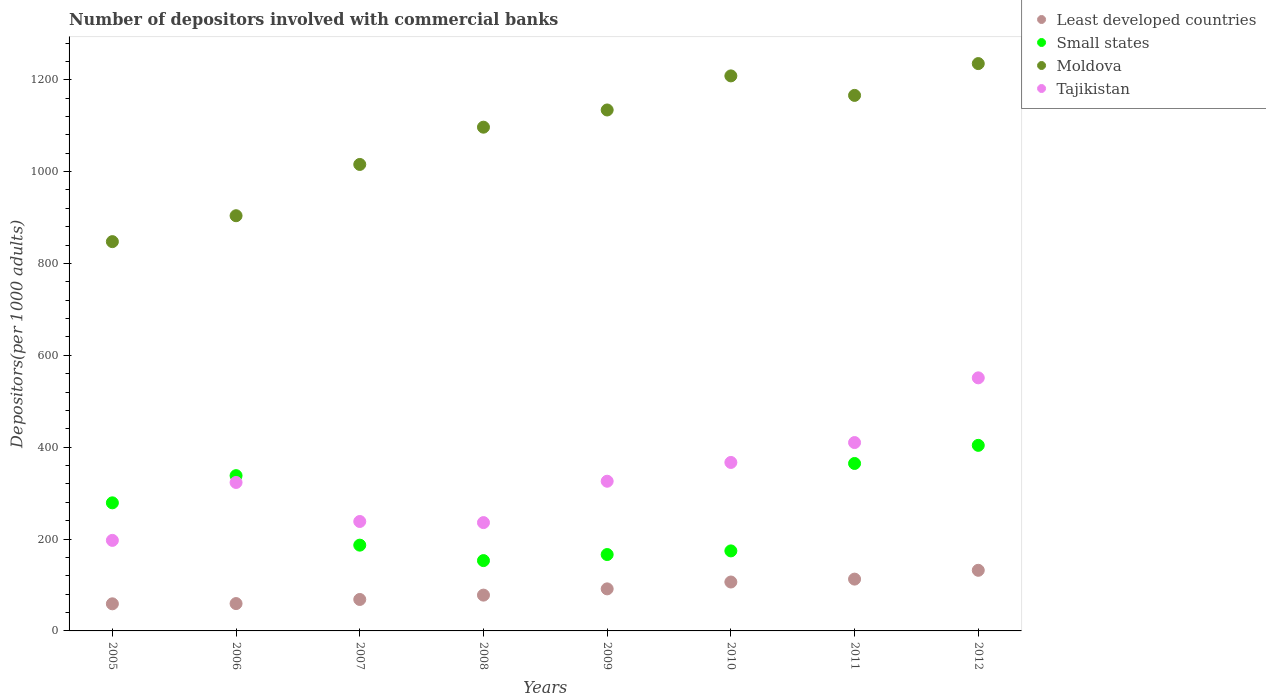How many different coloured dotlines are there?
Provide a short and direct response. 4. What is the number of depositors involved with commercial banks in Tajikistan in 2010?
Give a very brief answer. 366.8. Across all years, what is the maximum number of depositors involved with commercial banks in Tajikistan?
Provide a short and direct response. 550.99. Across all years, what is the minimum number of depositors involved with commercial banks in Moldova?
Your response must be concise. 847.53. What is the total number of depositors involved with commercial banks in Tajikistan in the graph?
Your response must be concise. 2648.21. What is the difference between the number of depositors involved with commercial banks in Least developed countries in 2005 and that in 2010?
Keep it short and to the point. -47.47. What is the difference between the number of depositors involved with commercial banks in Least developed countries in 2008 and the number of depositors involved with commercial banks in Moldova in 2012?
Your answer should be compact. -1157.23. What is the average number of depositors involved with commercial banks in Moldova per year?
Make the answer very short. 1075.94. In the year 2010, what is the difference between the number of depositors involved with commercial banks in Small states and number of depositors involved with commercial banks in Tajikistan?
Offer a terse response. -192.58. In how many years, is the number of depositors involved with commercial banks in Least developed countries greater than 640?
Your answer should be very brief. 0. What is the ratio of the number of depositors involved with commercial banks in Tajikistan in 2005 to that in 2007?
Keep it short and to the point. 0.83. Is the number of depositors involved with commercial banks in Moldova in 2006 less than that in 2012?
Your answer should be very brief. Yes. What is the difference between the highest and the second highest number of depositors involved with commercial banks in Tajikistan?
Offer a terse response. 140.89. What is the difference between the highest and the lowest number of depositors involved with commercial banks in Least developed countries?
Your response must be concise. 72.97. Is it the case that in every year, the sum of the number of depositors involved with commercial banks in Small states and number of depositors involved with commercial banks in Moldova  is greater than the number of depositors involved with commercial banks in Least developed countries?
Your answer should be compact. Yes. Does the number of depositors involved with commercial banks in Tajikistan monotonically increase over the years?
Offer a terse response. No. Is the number of depositors involved with commercial banks in Moldova strictly less than the number of depositors involved with commercial banks in Least developed countries over the years?
Keep it short and to the point. No. How many dotlines are there?
Your answer should be compact. 4. Are the values on the major ticks of Y-axis written in scientific E-notation?
Make the answer very short. No. Does the graph contain any zero values?
Make the answer very short. No. Does the graph contain grids?
Provide a succinct answer. No. Where does the legend appear in the graph?
Offer a terse response. Top right. What is the title of the graph?
Your answer should be compact. Number of depositors involved with commercial banks. Does "Nepal" appear as one of the legend labels in the graph?
Your response must be concise. No. What is the label or title of the X-axis?
Keep it short and to the point. Years. What is the label or title of the Y-axis?
Your answer should be compact. Depositors(per 1000 adults). What is the Depositors(per 1000 adults) of Least developed countries in 2005?
Keep it short and to the point. 59.02. What is the Depositors(per 1000 adults) of Small states in 2005?
Your answer should be very brief. 278.86. What is the Depositors(per 1000 adults) in Moldova in 2005?
Offer a very short reply. 847.53. What is the Depositors(per 1000 adults) in Tajikistan in 2005?
Offer a very short reply. 197.12. What is the Depositors(per 1000 adults) of Least developed countries in 2006?
Your answer should be compact. 59.54. What is the Depositors(per 1000 adults) in Small states in 2006?
Your response must be concise. 338.08. What is the Depositors(per 1000 adults) of Moldova in 2006?
Offer a terse response. 903.95. What is the Depositors(per 1000 adults) in Tajikistan in 2006?
Give a very brief answer. 323.23. What is the Depositors(per 1000 adults) in Least developed countries in 2007?
Offer a terse response. 68.48. What is the Depositors(per 1000 adults) of Small states in 2007?
Provide a short and direct response. 186.74. What is the Depositors(per 1000 adults) of Moldova in 2007?
Provide a succinct answer. 1015.6. What is the Depositors(per 1000 adults) in Tajikistan in 2007?
Give a very brief answer. 238.26. What is the Depositors(per 1000 adults) in Least developed countries in 2008?
Your answer should be compact. 77.95. What is the Depositors(per 1000 adults) of Small states in 2008?
Give a very brief answer. 153.11. What is the Depositors(per 1000 adults) in Moldova in 2008?
Keep it short and to the point. 1096.73. What is the Depositors(per 1000 adults) of Tajikistan in 2008?
Your answer should be very brief. 235.83. What is the Depositors(per 1000 adults) in Least developed countries in 2009?
Offer a very short reply. 91.54. What is the Depositors(per 1000 adults) of Small states in 2009?
Provide a succinct answer. 166.31. What is the Depositors(per 1000 adults) in Moldova in 2009?
Your answer should be compact. 1134.17. What is the Depositors(per 1000 adults) of Tajikistan in 2009?
Your answer should be very brief. 325.89. What is the Depositors(per 1000 adults) in Least developed countries in 2010?
Your answer should be very brief. 106.48. What is the Depositors(per 1000 adults) in Small states in 2010?
Give a very brief answer. 174.21. What is the Depositors(per 1000 adults) in Moldova in 2010?
Offer a terse response. 1208.39. What is the Depositors(per 1000 adults) of Tajikistan in 2010?
Your answer should be very brief. 366.8. What is the Depositors(per 1000 adults) of Least developed countries in 2011?
Offer a terse response. 112.8. What is the Depositors(per 1000 adults) of Small states in 2011?
Your response must be concise. 364.57. What is the Depositors(per 1000 adults) of Moldova in 2011?
Provide a succinct answer. 1165.93. What is the Depositors(per 1000 adults) in Tajikistan in 2011?
Give a very brief answer. 410.1. What is the Depositors(per 1000 adults) in Least developed countries in 2012?
Provide a succinct answer. 131.99. What is the Depositors(per 1000 adults) in Small states in 2012?
Ensure brevity in your answer.  404.02. What is the Depositors(per 1000 adults) in Moldova in 2012?
Make the answer very short. 1235.18. What is the Depositors(per 1000 adults) of Tajikistan in 2012?
Make the answer very short. 550.99. Across all years, what is the maximum Depositors(per 1000 adults) of Least developed countries?
Your response must be concise. 131.99. Across all years, what is the maximum Depositors(per 1000 adults) in Small states?
Give a very brief answer. 404.02. Across all years, what is the maximum Depositors(per 1000 adults) in Moldova?
Provide a short and direct response. 1235.18. Across all years, what is the maximum Depositors(per 1000 adults) of Tajikistan?
Provide a short and direct response. 550.99. Across all years, what is the minimum Depositors(per 1000 adults) in Least developed countries?
Provide a short and direct response. 59.02. Across all years, what is the minimum Depositors(per 1000 adults) in Small states?
Provide a short and direct response. 153.11. Across all years, what is the minimum Depositors(per 1000 adults) in Moldova?
Your response must be concise. 847.53. Across all years, what is the minimum Depositors(per 1000 adults) of Tajikistan?
Provide a short and direct response. 197.12. What is the total Depositors(per 1000 adults) in Least developed countries in the graph?
Give a very brief answer. 707.8. What is the total Depositors(per 1000 adults) in Small states in the graph?
Provide a short and direct response. 2065.89. What is the total Depositors(per 1000 adults) of Moldova in the graph?
Provide a succinct answer. 8607.5. What is the total Depositors(per 1000 adults) of Tajikistan in the graph?
Provide a succinct answer. 2648.21. What is the difference between the Depositors(per 1000 adults) in Least developed countries in 2005 and that in 2006?
Provide a succinct answer. -0.52. What is the difference between the Depositors(per 1000 adults) in Small states in 2005 and that in 2006?
Make the answer very short. -59.21. What is the difference between the Depositors(per 1000 adults) in Moldova in 2005 and that in 2006?
Your response must be concise. -56.41. What is the difference between the Depositors(per 1000 adults) in Tajikistan in 2005 and that in 2006?
Your response must be concise. -126.11. What is the difference between the Depositors(per 1000 adults) in Least developed countries in 2005 and that in 2007?
Your answer should be very brief. -9.47. What is the difference between the Depositors(per 1000 adults) of Small states in 2005 and that in 2007?
Offer a terse response. 92.12. What is the difference between the Depositors(per 1000 adults) of Moldova in 2005 and that in 2007?
Your answer should be compact. -168.07. What is the difference between the Depositors(per 1000 adults) in Tajikistan in 2005 and that in 2007?
Provide a succinct answer. -41.14. What is the difference between the Depositors(per 1000 adults) in Least developed countries in 2005 and that in 2008?
Your answer should be very brief. -18.94. What is the difference between the Depositors(per 1000 adults) of Small states in 2005 and that in 2008?
Provide a succinct answer. 125.76. What is the difference between the Depositors(per 1000 adults) of Moldova in 2005 and that in 2008?
Make the answer very short. -249.19. What is the difference between the Depositors(per 1000 adults) in Tajikistan in 2005 and that in 2008?
Your answer should be compact. -38.71. What is the difference between the Depositors(per 1000 adults) in Least developed countries in 2005 and that in 2009?
Keep it short and to the point. -32.53. What is the difference between the Depositors(per 1000 adults) of Small states in 2005 and that in 2009?
Your answer should be compact. 112.56. What is the difference between the Depositors(per 1000 adults) of Moldova in 2005 and that in 2009?
Give a very brief answer. -286.64. What is the difference between the Depositors(per 1000 adults) in Tajikistan in 2005 and that in 2009?
Ensure brevity in your answer.  -128.77. What is the difference between the Depositors(per 1000 adults) in Least developed countries in 2005 and that in 2010?
Offer a very short reply. -47.47. What is the difference between the Depositors(per 1000 adults) of Small states in 2005 and that in 2010?
Provide a succinct answer. 104.65. What is the difference between the Depositors(per 1000 adults) of Moldova in 2005 and that in 2010?
Your answer should be very brief. -360.86. What is the difference between the Depositors(per 1000 adults) of Tajikistan in 2005 and that in 2010?
Your answer should be compact. -169.68. What is the difference between the Depositors(per 1000 adults) of Least developed countries in 2005 and that in 2011?
Keep it short and to the point. -53.78. What is the difference between the Depositors(per 1000 adults) in Small states in 2005 and that in 2011?
Your response must be concise. -85.7. What is the difference between the Depositors(per 1000 adults) in Moldova in 2005 and that in 2011?
Give a very brief answer. -318.4. What is the difference between the Depositors(per 1000 adults) of Tajikistan in 2005 and that in 2011?
Give a very brief answer. -212.98. What is the difference between the Depositors(per 1000 adults) of Least developed countries in 2005 and that in 2012?
Offer a terse response. -72.97. What is the difference between the Depositors(per 1000 adults) of Small states in 2005 and that in 2012?
Offer a very short reply. -125.15. What is the difference between the Depositors(per 1000 adults) of Moldova in 2005 and that in 2012?
Ensure brevity in your answer.  -387.65. What is the difference between the Depositors(per 1000 adults) in Tajikistan in 2005 and that in 2012?
Ensure brevity in your answer.  -353.87. What is the difference between the Depositors(per 1000 adults) of Least developed countries in 2006 and that in 2007?
Give a very brief answer. -8.94. What is the difference between the Depositors(per 1000 adults) of Small states in 2006 and that in 2007?
Your answer should be compact. 151.33. What is the difference between the Depositors(per 1000 adults) in Moldova in 2006 and that in 2007?
Your response must be concise. -111.65. What is the difference between the Depositors(per 1000 adults) in Tajikistan in 2006 and that in 2007?
Provide a succinct answer. 84.98. What is the difference between the Depositors(per 1000 adults) of Least developed countries in 2006 and that in 2008?
Your response must be concise. -18.41. What is the difference between the Depositors(per 1000 adults) in Small states in 2006 and that in 2008?
Your answer should be compact. 184.97. What is the difference between the Depositors(per 1000 adults) in Moldova in 2006 and that in 2008?
Provide a short and direct response. -192.78. What is the difference between the Depositors(per 1000 adults) of Tajikistan in 2006 and that in 2008?
Your answer should be very brief. 87.4. What is the difference between the Depositors(per 1000 adults) in Least developed countries in 2006 and that in 2009?
Your answer should be very brief. -32. What is the difference between the Depositors(per 1000 adults) of Small states in 2006 and that in 2009?
Your answer should be compact. 171.77. What is the difference between the Depositors(per 1000 adults) in Moldova in 2006 and that in 2009?
Your answer should be compact. -230.23. What is the difference between the Depositors(per 1000 adults) in Tajikistan in 2006 and that in 2009?
Offer a very short reply. -2.66. What is the difference between the Depositors(per 1000 adults) of Least developed countries in 2006 and that in 2010?
Offer a very short reply. -46.94. What is the difference between the Depositors(per 1000 adults) in Small states in 2006 and that in 2010?
Keep it short and to the point. 163.86. What is the difference between the Depositors(per 1000 adults) of Moldova in 2006 and that in 2010?
Ensure brevity in your answer.  -304.44. What is the difference between the Depositors(per 1000 adults) of Tajikistan in 2006 and that in 2010?
Ensure brevity in your answer.  -43.56. What is the difference between the Depositors(per 1000 adults) in Least developed countries in 2006 and that in 2011?
Offer a terse response. -53.26. What is the difference between the Depositors(per 1000 adults) in Small states in 2006 and that in 2011?
Give a very brief answer. -26.49. What is the difference between the Depositors(per 1000 adults) of Moldova in 2006 and that in 2011?
Offer a very short reply. -261.98. What is the difference between the Depositors(per 1000 adults) in Tajikistan in 2006 and that in 2011?
Your answer should be very brief. -86.87. What is the difference between the Depositors(per 1000 adults) in Least developed countries in 2006 and that in 2012?
Provide a short and direct response. -72.45. What is the difference between the Depositors(per 1000 adults) in Small states in 2006 and that in 2012?
Offer a terse response. -65.94. What is the difference between the Depositors(per 1000 adults) in Moldova in 2006 and that in 2012?
Give a very brief answer. -331.24. What is the difference between the Depositors(per 1000 adults) in Tajikistan in 2006 and that in 2012?
Make the answer very short. -227.76. What is the difference between the Depositors(per 1000 adults) in Least developed countries in 2007 and that in 2008?
Give a very brief answer. -9.47. What is the difference between the Depositors(per 1000 adults) of Small states in 2007 and that in 2008?
Make the answer very short. 33.63. What is the difference between the Depositors(per 1000 adults) of Moldova in 2007 and that in 2008?
Give a very brief answer. -81.13. What is the difference between the Depositors(per 1000 adults) in Tajikistan in 2007 and that in 2008?
Offer a terse response. 2.43. What is the difference between the Depositors(per 1000 adults) in Least developed countries in 2007 and that in 2009?
Keep it short and to the point. -23.06. What is the difference between the Depositors(per 1000 adults) of Small states in 2007 and that in 2009?
Provide a short and direct response. 20.43. What is the difference between the Depositors(per 1000 adults) of Moldova in 2007 and that in 2009?
Provide a short and direct response. -118.57. What is the difference between the Depositors(per 1000 adults) in Tajikistan in 2007 and that in 2009?
Your answer should be very brief. -87.64. What is the difference between the Depositors(per 1000 adults) of Least developed countries in 2007 and that in 2010?
Make the answer very short. -38. What is the difference between the Depositors(per 1000 adults) of Small states in 2007 and that in 2010?
Provide a succinct answer. 12.53. What is the difference between the Depositors(per 1000 adults) in Moldova in 2007 and that in 2010?
Your answer should be compact. -192.79. What is the difference between the Depositors(per 1000 adults) of Tajikistan in 2007 and that in 2010?
Your answer should be very brief. -128.54. What is the difference between the Depositors(per 1000 adults) in Least developed countries in 2007 and that in 2011?
Offer a terse response. -44.32. What is the difference between the Depositors(per 1000 adults) in Small states in 2007 and that in 2011?
Offer a terse response. -177.83. What is the difference between the Depositors(per 1000 adults) in Moldova in 2007 and that in 2011?
Your answer should be very brief. -150.33. What is the difference between the Depositors(per 1000 adults) in Tajikistan in 2007 and that in 2011?
Keep it short and to the point. -171.84. What is the difference between the Depositors(per 1000 adults) in Least developed countries in 2007 and that in 2012?
Your answer should be very brief. -63.51. What is the difference between the Depositors(per 1000 adults) of Small states in 2007 and that in 2012?
Offer a very short reply. -217.28. What is the difference between the Depositors(per 1000 adults) of Moldova in 2007 and that in 2012?
Provide a succinct answer. -219.58. What is the difference between the Depositors(per 1000 adults) in Tajikistan in 2007 and that in 2012?
Provide a succinct answer. -312.74. What is the difference between the Depositors(per 1000 adults) of Least developed countries in 2008 and that in 2009?
Your response must be concise. -13.59. What is the difference between the Depositors(per 1000 adults) of Small states in 2008 and that in 2009?
Your answer should be very brief. -13.2. What is the difference between the Depositors(per 1000 adults) of Moldova in 2008 and that in 2009?
Provide a succinct answer. -37.44. What is the difference between the Depositors(per 1000 adults) in Tajikistan in 2008 and that in 2009?
Provide a succinct answer. -90.06. What is the difference between the Depositors(per 1000 adults) in Least developed countries in 2008 and that in 2010?
Your response must be concise. -28.53. What is the difference between the Depositors(per 1000 adults) in Small states in 2008 and that in 2010?
Your answer should be very brief. -21.11. What is the difference between the Depositors(per 1000 adults) of Moldova in 2008 and that in 2010?
Your answer should be compact. -111.66. What is the difference between the Depositors(per 1000 adults) of Tajikistan in 2008 and that in 2010?
Give a very brief answer. -130.97. What is the difference between the Depositors(per 1000 adults) in Least developed countries in 2008 and that in 2011?
Make the answer very short. -34.85. What is the difference between the Depositors(per 1000 adults) of Small states in 2008 and that in 2011?
Your response must be concise. -211.46. What is the difference between the Depositors(per 1000 adults) of Moldova in 2008 and that in 2011?
Offer a terse response. -69.2. What is the difference between the Depositors(per 1000 adults) of Tajikistan in 2008 and that in 2011?
Ensure brevity in your answer.  -174.27. What is the difference between the Depositors(per 1000 adults) in Least developed countries in 2008 and that in 2012?
Provide a short and direct response. -54.04. What is the difference between the Depositors(per 1000 adults) in Small states in 2008 and that in 2012?
Make the answer very short. -250.91. What is the difference between the Depositors(per 1000 adults) of Moldova in 2008 and that in 2012?
Your answer should be compact. -138.45. What is the difference between the Depositors(per 1000 adults) in Tajikistan in 2008 and that in 2012?
Provide a succinct answer. -315.16. What is the difference between the Depositors(per 1000 adults) of Least developed countries in 2009 and that in 2010?
Offer a terse response. -14.94. What is the difference between the Depositors(per 1000 adults) in Small states in 2009 and that in 2010?
Provide a succinct answer. -7.91. What is the difference between the Depositors(per 1000 adults) in Moldova in 2009 and that in 2010?
Provide a succinct answer. -74.22. What is the difference between the Depositors(per 1000 adults) in Tajikistan in 2009 and that in 2010?
Offer a terse response. -40.9. What is the difference between the Depositors(per 1000 adults) in Least developed countries in 2009 and that in 2011?
Keep it short and to the point. -21.26. What is the difference between the Depositors(per 1000 adults) of Small states in 2009 and that in 2011?
Your answer should be very brief. -198.26. What is the difference between the Depositors(per 1000 adults) in Moldova in 2009 and that in 2011?
Offer a very short reply. -31.76. What is the difference between the Depositors(per 1000 adults) of Tajikistan in 2009 and that in 2011?
Your response must be concise. -84.21. What is the difference between the Depositors(per 1000 adults) of Least developed countries in 2009 and that in 2012?
Make the answer very short. -40.44. What is the difference between the Depositors(per 1000 adults) of Small states in 2009 and that in 2012?
Provide a succinct answer. -237.71. What is the difference between the Depositors(per 1000 adults) of Moldova in 2009 and that in 2012?
Provide a succinct answer. -101.01. What is the difference between the Depositors(per 1000 adults) in Tajikistan in 2009 and that in 2012?
Provide a short and direct response. -225.1. What is the difference between the Depositors(per 1000 adults) in Least developed countries in 2010 and that in 2011?
Your answer should be compact. -6.32. What is the difference between the Depositors(per 1000 adults) of Small states in 2010 and that in 2011?
Give a very brief answer. -190.35. What is the difference between the Depositors(per 1000 adults) of Moldova in 2010 and that in 2011?
Your response must be concise. 42.46. What is the difference between the Depositors(per 1000 adults) of Tajikistan in 2010 and that in 2011?
Your answer should be compact. -43.3. What is the difference between the Depositors(per 1000 adults) in Least developed countries in 2010 and that in 2012?
Your response must be concise. -25.51. What is the difference between the Depositors(per 1000 adults) of Small states in 2010 and that in 2012?
Make the answer very short. -229.8. What is the difference between the Depositors(per 1000 adults) in Moldova in 2010 and that in 2012?
Offer a terse response. -26.79. What is the difference between the Depositors(per 1000 adults) of Tajikistan in 2010 and that in 2012?
Your answer should be compact. -184.2. What is the difference between the Depositors(per 1000 adults) in Least developed countries in 2011 and that in 2012?
Your response must be concise. -19.19. What is the difference between the Depositors(per 1000 adults) in Small states in 2011 and that in 2012?
Your answer should be compact. -39.45. What is the difference between the Depositors(per 1000 adults) of Moldova in 2011 and that in 2012?
Ensure brevity in your answer.  -69.25. What is the difference between the Depositors(per 1000 adults) in Tajikistan in 2011 and that in 2012?
Offer a very short reply. -140.89. What is the difference between the Depositors(per 1000 adults) of Least developed countries in 2005 and the Depositors(per 1000 adults) of Small states in 2006?
Your answer should be compact. -279.06. What is the difference between the Depositors(per 1000 adults) in Least developed countries in 2005 and the Depositors(per 1000 adults) in Moldova in 2006?
Your response must be concise. -844.93. What is the difference between the Depositors(per 1000 adults) in Least developed countries in 2005 and the Depositors(per 1000 adults) in Tajikistan in 2006?
Your answer should be very brief. -264.22. What is the difference between the Depositors(per 1000 adults) of Small states in 2005 and the Depositors(per 1000 adults) of Moldova in 2006?
Provide a short and direct response. -625.09. What is the difference between the Depositors(per 1000 adults) in Small states in 2005 and the Depositors(per 1000 adults) in Tajikistan in 2006?
Your answer should be very brief. -44.37. What is the difference between the Depositors(per 1000 adults) in Moldova in 2005 and the Depositors(per 1000 adults) in Tajikistan in 2006?
Offer a very short reply. 524.3. What is the difference between the Depositors(per 1000 adults) in Least developed countries in 2005 and the Depositors(per 1000 adults) in Small states in 2007?
Provide a succinct answer. -127.73. What is the difference between the Depositors(per 1000 adults) of Least developed countries in 2005 and the Depositors(per 1000 adults) of Moldova in 2007?
Your answer should be compact. -956.59. What is the difference between the Depositors(per 1000 adults) of Least developed countries in 2005 and the Depositors(per 1000 adults) of Tajikistan in 2007?
Ensure brevity in your answer.  -179.24. What is the difference between the Depositors(per 1000 adults) of Small states in 2005 and the Depositors(per 1000 adults) of Moldova in 2007?
Provide a short and direct response. -736.74. What is the difference between the Depositors(per 1000 adults) in Small states in 2005 and the Depositors(per 1000 adults) in Tajikistan in 2007?
Your answer should be compact. 40.61. What is the difference between the Depositors(per 1000 adults) of Moldova in 2005 and the Depositors(per 1000 adults) of Tajikistan in 2007?
Keep it short and to the point. 609.28. What is the difference between the Depositors(per 1000 adults) in Least developed countries in 2005 and the Depositors(per 1000 adults) in Small states in 2008?
Keep it short and to the point. -94.09. What is the difference between the Depositors(per 1000 adults) in Least developed countries in 2005 and the Depositors(per 1000 adults) in Moldova in 2008?
Provide a succinct answer. -1037.71. What is the difference between the Depositors(per 1000 adults) in Least developed countries in 2005 and the Depositors(per 1000 adults) in Tajikistan in 2008?
Keep it short and to the point. -176.81. What is the difference between the Depositors(per 1000 adults) in Small states in 2005 and the Depositors(per 1000 adults) in Moldova in 2008?
Your response must be concise. -817.87. What is the difference between the Depositors(per 1000 adults) of Small states in 2005 and the Depositors(per 1000 adults) of Tajikistan in 2008?
Your response must be concise. 43.04. What is the difference between the Depositors(per 1000 adults) of Moldova in 2005 and the Depositors(per 1000 adults) of Tajikistan in 2008?
Your answer should be compact. 611.71. What is the difference between the Depositors(per 1000 adults) of Least developed countries in 2005 and the Depositors(per 1000 adults) of Small states in 2009?
Your answer should be very brief. -107.29. What is the difference between the Depositors(per 1000 adults) of Least developed countries in 2005 and the Depositors(per 1000 adults) of Moldova in 2009?
Offer a terse response. -1075.16. What is the difference between the Depositors(per 1000 adults) of Least developed countries in 2005 and the Depositors(per 1000 adults) of Tajikistan in 2009?
Ensure brevity in your answer.  -266.88. What is the difference between the Depositors(per 1000 adults) in Small states in 2005 and the Depositors(per 1000 adults) in Moldova in 2009?
Keep it short and to the point. -855.31. What is the difference between the Depositors(per 1000 adults) of Small states in 2005 and the Depositors(per 1000 adults) of Tajikistan in 2009?
Offer a very short reply. -47.03. What is the difference between the Depositors(per 1000 adults) of Moldova in 2005 and the Depositors(per 1000 adults) of Tajikistan in 2009?
Provide a succinct answer. 521.64. What is the difference between the Depositors(per 1000 adults) of Least developed countries in 2005 and the Depositors(per 1000 adults) of Small states in 2010?
Offer a very short reply. -115.2. What is the difference between the Depositors(per 1000 adults) in Least developed countries in 2005 and the Depositors(per 1000 adults) in Moldova in 2010?
Your answer should be compact. -1149.38. What is the difference between the Depositors(per 1000 adults) of Least developed countries in 2005 and the Depositors(per 1000 adults) of Tajikistan in 2010?
Keep it short and to the point. -307.78. What is the difference between the Depositors(per 1000 adults) of Small states in 2005 and the Depositors(per 1000 adults) of Moldova in 2010?
Provide a succinct answer. -929.53. What is the difference between the Depositors(per 1000 adults) of Small states in 2005 and the Depositors(per 1000 adults) of Tajikistan in 2010?
Your answer should be compact. -87.93. What is the difference between the Depositors(per 1000 adults) in Moldova in 2005 and the Depositors(per 1000 adults) in Tajikistan in 2010?
Keep it short and to the point. 480.74. What is the difference between the Depositors(per 1000 adults) in Least developed countries in 2005 and the Depositors(per 1000 adults) in Small states in 2011?
Your answer should be compact. -305.55. What is the difference between the Depositors(per 1000 adults) in Least developed countries in 2005 and the Depositors(per 1000 adults) in Moldova in 2011?
Provide a succinct answer. -1106.92. What is the difference between the Depositors(per 1000 adults) in Least developed countries in 2005 and the Depositors(per 1000 adults) in Tajikistan in 2011?
Provide a short and direct response. -351.08. What is the difference between the Depositors(per 1000 adults) of Small states in 2005 and the Depositors(per 1000 adults) of Moldova in 2011?
Provide a short and direct response. -887.07. What is the difference between the Depositors(per 1000 adults) of Small states in 2005 and the Depositors(per 1000 adults) of Tajikistan in 2011?
Your answer should be compact. -131.24. What is the difference between the Depositors(per 1000 adults) of Moldova in 2005 and the Depositors(per 1000 adults) of Tajikistan in 2011?
Offer a terse response. 437.44. What is the difference between the Depositors(per 1000 adults) of Least developed countries in 2005 and the Depositors(per 1000 adults) of Small states in 2012?
Keep it short and to the point. -345. What is the difference between the Depositors(per 1000 adults) of Least developed countries in 2005 and the Depositors(per 1000 adults) of Moldova in 2012?
Keep it short and to the point. -1176.17. What is the difference between the Depositors(per 1000 adults) in Least developed countries in 2005 and the Depositors(per 1000 adults) in Tajikistan in 2012?
Provide a succinct answer. -491.98. What is the difference between the Depositors(per 1000 adults) in Small states in 2005 and the Depositors(per 1000 adults) in Moldova in 2012?
Offer a very short reply. -956.32. What is the difference between the Depositors(per 1000 adults) of Small states in 2005 and the Depositors(per 1000 adults) of Tajikistan in 2012?
Your response must be concise. -272.13. What is the difference between the Depositors(per 1000 adults) in Moldova in 2005 and the Depositors(per 1000 adults) in Tajikistan in 2012?
Give a very brief answer. 296.54. What is the difference between the Depositors(per 1000 adults) of Least developed countries in 2006 and the Depositors(per 1000 adults) of Small states in 2007?
Make the answer very short. -127.2. What is the difference between the Depositors(per 1000 adults) in Least developed countries in 2006 and the Depositors(per 1000 adults) in Moldova in 2007?
Ensure brevity in your answer.  -956.06. What is the difference between the Depositors(per 1000 adults) of Least developed countries in 2006 and the Depositors(per 1000 adults) of Tajikistan in 2007?
Ensure brevity in your answer.  -178.72. What is the difference between the Depositors(per 1000 adults) in Small states in 2006 and the Depositors(per 1000 adults) in Moldova in 2007?
Provide a succinct answer. -677.53. What is the difference between the Depositors(per 1000 adults) in Small states in 2006 and the Depositors(per 1000 adults) in Tajikistan in 2007?
Keep it short and to the point. 99.82. What is the difference between the Depositors(per 1000 adults) in Moldova in 2006 and the Depositors(per 1000 adults) in Tajikistan in 2007?
Offer a terse response. 665.69. What is the difference between the Depositors(per 1000 adults) of Least developed countries in 2006 and the Depositors(per 1000 adults) of Small states in 2008?
Ensure brevity in your answer.  -93.57. What is the difference between the Depositors(per 1000 adults) of Least developed countries in 2006 and the Depositors(per 1000 adults) of Moldova in 2008?
Keep it short and to the point. -1037.19. What is the difference between the Depositors(per 1000 adults) of Least developed countries in 2006 and the Depositors(per 1000 adults) of Tajikistan in 2008?
Provide a short and direct response. -176.29. What is the difference between the Depositors(per 1000 adults) of Small states in 2006 and the Depositors(per 1000 adults) of Moldova in 2008?
Give a very brief answer. -758.65. What is the difference between the Depositors(per 1000 adults) of Small states in 2006 and the Depositors(per 1000 adults) of Tajikistan in 2008?
Make the answer very short. 102.25. What is the difference between the Depositors(per 1000 adults) in Moldova in 2006 and the Depositors(per 1000 adults) in Tajikistan in 2008?
Ensure brevity in your answer.  668.12. What is the difference between the Depositors(per 1000 adults) in Least developed countries in 2006 and the Depositors(per 1000 adults) in Small states in 2009?
Your answer should be very brief. -106.77. What is the difference between the Depositors(per 1000 adults) of Least developed countries in 2006 and the Depositors(per 1000 adults) of Moldova in 2009?
Make the answer very short. -1074.64. What is the difference between the Depositors(per 1000 adults) in Least developed countries in 2006 and the Depositors(per 1000 adults) in Tajikistan in 2009?
Make the answer very short. -266.35. What is the difference between the Depositors(per 1000 adults) of Small states in 2006 and the Depositors(per 1000 adults) of Moldova in 2009?
Provide a succinct answer. -796.1. What is the difference between the Depositors(per 1000 adults) of Small states in 2006 and the Depositors(per 1000 adults) of Tajikistan in 2009?
Ensure brevity in your answer.  12.18. What is the difference between the Depositors(per 1000 adults) of Moldova in 2006 and the Depositors(per 1000 adults) of Tajikistan in 2009?
Your answer should be compact. 578.06. What is the difference between the Depositors(per 1000 adults) in Least developed countries in 2006 and the Depositors(per 1000 adults) in Small states in 2010?
Provide a short and direct response. -114.68. What is the difference between the Depositors(per 1000 adults) of Least developed countries in 2006 and the Depositors(per 1000 adults) of Moldova in 2010?
Ensure brevity in your answer.  -1148.85. What is the difference between the Depositors(per 1000 adults) in Least developed countries in 2006 and the Depositors(per 1000 adults) in Tajikistan in 2010?
Keep it short and to the point. -307.26. What is the difference between the Depositors(per 1000 adults) of Small states in 2006 and the Depositors(per 1000 adults) of Moldova in 2010?
Provide a succinct answer. -870.32. What is the difference between the Depositors(per 1000 adults) of Small states in 2006 and the Depositors(per 1000 adults) of Tajikistan in 2010?
Your answer should be compact. -28.72. What is the difference between the Depositors(per 1000 adults) of Moldova in 2006 and the Depositors(per 1000 adults) of Tajikistan in 2010?
Make the answer very short. 537.15. What is the difference between the Depositors(per 1000 adults) in Least developed countries in 2006 and the Depositors(per 1000 adults) in Small states in 2011?
Provide a succinct answer. -305.03. What is the difference between the Depositors(per 1000 adults) of Least developed countries in 2006 and the Depositors(per 1000 adults) of Moldova in 2011?
Make the answer very short. -1106.39. What is the difference between the Depositors(per 1000 adults) in Least developed countries in 2006 and the Depositors(per 1000 adults) in Tajikistan in 2011?
Give a very brief answer. -350.56. What is the difference between the Depositors(per 1000 adults) in Small states in 2006 and the Depositors(per 1000 adults) in Moldova in 2011?
Your response must be concise. -827.86. What is the difference between the Depositors(per 1000 adults) in Small states in 2006 and the Depositors(per 1000 adults) in Tajikistan in 2011?
Provide a short and direct response. -72.02. What is the difference between the Depositors(per 1000 adults) in Moldova in 2006 and the Depositors(per 1000 adults) in Tajikistan in 2011?
Provide a succinct answer. 493.85. What is the difference between the Depositors(per 1000 adults) of Least developed countries in 2006 and the Depositors(per 1000 adults) of Small states in 2012?
Provide a short and direct response. -344.48. What is the difference between the Depositors(per 1000 adults) in Least developed countries in 2006 and the Depositors(per 1000 adults) in Moldova in 2012?
Your response must be concise. -1175.65. What is the difference between the Depositors(per 1000 adults) in Least developed countries in 2006 and the Depositors(per 1000 adults) in Tajikistan in 2012?
Your answer should be compact. -491.45. What is the difference between the Depositors(per 1000 adults) of Small states in 2006 and the Depositors(per 1000 adults) of Moldova in 2012?
Make the answer very short. -897.11. What is the difference between the Depositors(per 1000 adults) of Small states in 2006 and the Depositors(per 1000 adults) of Tajikistan in 2012?
Keep it short and to the point. -212.92. What is the difference between the Depositors(per 1000 adults) of Moldova in 2006 and the Depositors(per 1000 adults) of Tajikistan in 2012?
Your response must be concise. 352.96. What is the difference between the Depositors(per 1000 adults) in Least developed countries in 2007 and the Depositors(per 1000 adults) in Small states in 2008?
Keep it short and to the point. -84.63. What is the difference between the Depositors(per 1000 adults) of Least developed countries in 2007 and the Depositors(per 1000 adults) of Moldova in 2008?
Offer a terse response. -1028.25. What is the difference between the Depositors(per 1000 adults) of Least developed countries in 2007 and the Depositors(per 1000 adults) of Tajikistan in 2008?
Give a very brief answer. -167.35. What is the difference between the Depositors(per 1000 adults) of Small states in 2007 and the Depositors(per 1000 adults) of Moldova in 2008?
Provide a short and direct response. -909.99. What is the difference between the Depositors(per 1000 adults) of Small states in 2007 and the Depositors(per 1000 adults) of Tajikistan in 2008?
Your answer should be very brief. -49.09. What is the difference between the Depositors(per 1000 adults) of Moldova in 2007 and the Depositors(per 1000 adults) of Tajikistan in 2008?
Provide a short and direct response. 779.77. What is the difference between the Depositors(per 1000 adults) of Least developed countries in 2007 and the Depositors(per 1000 adults) of Small states in 2009?
Ensure brevity in your answer.  -97.83. What is the difference between the Depositors(per 1000 adults) of Least developed countries in 2007 and the Depositors(per 1000 adults) of Moldova in 2009?
Your response must be concise. -1065.69. What is the difference between the Depositors(per 1000 adults) of Least developed countries in 2007 and the Depositors(per 1000 adults) of Tajikistan in 2009?
Give a very brief answer. -257.41. What is the difference between the Depositors(per 1000 adults) of Small states in 2007 and the Depositors(per 1000 adults) of Moldova in 2009?
Your answer should be compact. -947.43. What is the difference between the Depositors(per 1000 adults) of Small states in 2007 and the Depositors(per 1000 adults) of Tajikistan in 2009?
Offer a very short reply. -139.15. What is the difference between the Depositors(per 1000 adults) in Moldova in 2007 and the Depositors(per 1000 adults) in Tajikistan in 2009?
Ensure brevity in your answer.  689.71. What is the difference between the Depositors(per 1000 adults) of Least developed countries in 2007 and the Depositors(per 1000 adults) of Small states in 2010?
Ensure brevity in your answer.  -105.73. What is the difference between the Depositors(per 1000 adults) in Least developed countries in 2007 and the Depositors(per 1000 adults) in Moldova in 2010?
Offer a terse response. -1139.91. What is the difference between the Depositors(per 1000 adults) in Least developed countries in 2007 and the Depositors(per 1000 adults) in Tajikistan in 2010?
Give a very brief answer. -298.32. What is the difference between the Depositors(per 1000 adults) of Small states in 2007 and the Depositors(per 1000 adults) of Moldova in 2010?
Make the answer very short. -1021.65. What is the difference between the Depositors(per 1000 adults) in Small states in 2007 and the Depositors(per 1000 adults) in Tajikistan in 2010?
Provide a succinct answer. -180.06. What is the difference between the Depositors(per 1000 adults) of Moldova in 2007 and the Depositors(per 1000 adults) of Tajikistan in 2010?
Your answer should be compact. 648.81. What is the difference between the Depositors(per 1000 adults) in Least developed countries in 2007 and the Depositors(per 1000 adults) in Small states in 2011?
Offer a very short reply. -296.09. What is the difference between the Depositors(per 1000 adults) of Least developed countries in 2007 and the Depositors(per 1000 adults) of Moldova in 2011?
Your response must be concise. -1097.45. What is the difference between the Depositors(per 1000 adults) in Least developed countries in 2007 and the Depositors(per 1000 adults) in Tajikistan in 2011?
Your answer should be compact. -341.62. What is the difference between the Depositors(per 1000 adults) in Small states in 2007 and the Depositors(per 1000 adults) in Moldova in 2011?
Offer a very short reply. -979.19. What is the difference between the Depositors(per 1000 adults) in Small states in 2007 and the Depositors(per 1000 adults) in Tajikistan in 2011?
Your answer should be compact. -223.36. What is the difference between the Depositors(per 1000 adults) in Moldova in 2007 and the Depositors(per 1000 adults) in Tajikistan in 2011?
Ensure brevity in your answer.  605.5. What is the difference between the Depositors(per 1000 adults) in Least developed countries in 2007 and the Depositors(per 1000 adults) in Small states in 2012?
Your response must be concise. -335.54. What is the difference between the Depositors(per 1000 adults) in Least developed countries in 2007 and the Depositors(per 1000 adults) in Moldova in 2012?
Offer a very short reply. -1166.7. What is the difference between the Depositors(per 1000 adults) of Least developed countries in 2007 and the Depositors(per 1000 adults) of Tajikistan in 2012?
Your answer should be compact. -482.51. What is the difference between the Depositors(per 1000 adults) of Small states in 2007 and the Depositors(per 1000 adults) of Moldova in 2012?
Offer a terse response. -1048.44. What is the difference between the Depositors(per 1000 adults) in Small states in 2007 and the Depositors(per 1000 adults) in Tajikistan in 2012?
Offer a very short reply. -364.25. What is the difference between the Depositors(per 1000 adults) in Moldova in 2007 and the Depositors(per 1000 adults) in Tajikistan in 2012?
Give a very brief answer. 464.61. What is the difference between the Depositors(per 1000 adults) of Least developed countries in 2008 and the Depositors(per 1000 adults) of Small states in 2009?
Give a very brief answer. -88.36. What is the difference between the Depositors(per 1000 adults) of Least developed countries in 2008 and the Depositors(per 1000 adults) of Moldova in 2009?
Your answer should be very brief. -1056.22. What is the difference between the Depositors(per 1000 adults) of Least developed countries in 2008 and the Depositors(per 1000 adults) of Tajikistan in 2009?
Ensure brevity in your answer.  -247.94. What is the difference between the Depositors(per 1000 adults) in Small states in 2008 and the Depositors(per 1000 adults) in Moldova in 2009?
Your answer should be compact. -981.07. What is the difference between the Depositors(per 1000 adults) in Small states in 2008 and the Depositors(per 1000 adults) in Tajikistan in 2009?
Keep it short and to the point. -172.79. What is the difference between the Depositors(per 1000 adults) of Moldova in 2008 and the Depositors(per 1000 adults) of Tajikistan in 2009?
Make the answer very short. 770.84. What is the difference between the Depositors(per 1000 adults) in Least developed countries in 2008 and the Depositors(per 1000 adults) in Small states in 2010?
Offer a terse response. -96.26. What is the difference between the Depositors(per 1000 adults) in Least developed countries in 2008 and the Depositors(per 1000 adults) in Moldova in 2010?
Provide a short and direct response. -1130.44. What is the difference between the Depositors(per 1000 adults) in Least developed countries in 2008 and the Depositors(per 1000 adults) in Tajikistan in 2010?
Your answer should be very brief. -288.85. What is the difference between the Depositors(per 1000 adults) in Small states in 2008 and the Depositors(per 1000 adults) in Moldova in 2010?
Keep it short and to the point. -1055.28. What is the difference between the Depositors(per 1000 adults) in Small states in 2008 and the Depositors(per 1000 adults) in Tajikistan in 2010?
Provide a succinct answer. -213.69. What is the difference between the Depositors(per 1000 adults) in Moldova in 2008 and the Depositors(per 1000 adults) in Tajikistan in 2010?
Provide a succinct answer. 729.93. What is the difference between the Depositors(per 1000 adults) of Least developed countries in 2008 and the Depositors(per 1000 adults) of Small states in 2011?
Make the answer very short. -286.62. What is the difference between the Depositors(per 1000 adults) of Least developed countries in 2008 and the Depositors(per 1000 adults) of Moldova in 2011?
Your answer should be compact. -1087.98. What is the difference between the Depositors(per 1000 adults) of Least developed countries in 2008 and the Depositors(per 1000 adults) of Tajikistan in 2011?
Give a very brief answer. -332.15. What is the difference between the Depositors(per 1000 adults) in Small states in 2008 and the Depositors(per 1000 adults) in Moldova in 2011?
Your answer should be compact. -1012.82. What is the difference between the Depositors(per 1000 adults) of Small states in 2008 and the Depositors(per 1000 adults) of Tajikistan in 2011?
Make the answer very short. -256.99. What is the difference between the Depositors(per 1000 adults) of Moldova in 2008 and the Depositors(per 1000 adults) of Tajikistan in 2011?
Your response must be concise. 686.63. What is the difference between the Depositors(per 1000 adults) of Least developed countries in 2008 and the Depositors(per 1000 adults) of Small states in 2012?
Your response must be concise. -326.07. What is the difference between the Depositors(per 1000 adults) of Least developed countries in 2008 and the Depositors(per 1000 adults) of Moldova in 2012?
Offer a very short reply. -1157.23. What is the difference between the Depositors(per 1000 adults) of Least developed countries in 2008 and the Depositors(per 1000 adults) of Tajikistan in 2012?
Your answer should be very brief. -473.04. What is the difference between the Depositors(per 1000 adults) of Small states in 2008 and the Depositors(per 1000 adults) of Moldova in 2012?
Your answer should be compact. -1082.08. What is the difference between the Depositors(per 1000 adults) in Small states in 2008 and the Depositors(per 1000 adults) in Tajikistan in 2012?
Provide a short and direct response. -397.89. What is the difference between the Depositors(per 1000 adults) of Moldova in 2008 and the Depositors(per 1000 adults) of Tajikistan in 2012?
Make the answer very short. 545.74. What is the difference between the Depositors(per 1000 adults) in Least developed countries in 2009 and the Depositors(per 1000 adults) in Small states in 2010?
Offer a terse response. -82.67. What is the difference between the Depositors(per 1000 adults) in Least developed countries in 2009 and the Depositors(per 1000 adults) in Moldova in 2010?
Make the answer very short. -1116.85. What is the difference between the Depositors(per 1000 adults) of Least developed countries in 2009 and the Depositors(per 1000 adults) of Tajikistan in 2010?
Offer a terse response. -275.25. What is the difference between the Depositors(per 1000 adults) of Small states in 2009 and the Depositors(per 1000 adults) of Moldova in 2010?
Keep it short and to the point. -1042.08. What is the difference between the Depositors(per 1000 adults) in Small states in 2009 and the Depositors(per 1000 adults) in Tajikistan in 2010?
Your response must be concise. -200.49. What is the difference between the Depositors(per 1000 adults) of Moldova in 2009 and the Depositors(per 1000 adults) of Tajikistan in 2010?
Keep it short and to the point. 767.38. What is the difference between the Depositors(per 1000 adults) of Least developed countries in 2009 and the Depositors(per 1000 adults) of Small states in 2011?
Keep it short and to the point. -273.02. What is the difference between the Depositors(per 1000 adults) of Least developed countries in 2009 and the Depositors(per 1000 adults) of Moldova in 2011?
Your response must be concise. -1074.39. What is the difference between the Depositors(per 1000 adults) of Least developed countries in 2009 and the Depositors(per 1000 adults) of Tajikistan in 2011?
Offer a terse response. -318.56. What is the difference between the Depositors(per 1000 adults) of Small states in 2009 and the Depositors(per 1000 adults) of Moldova in 2011?
Offer a very short reply. -999.62. What is the difference between the Depositors(per 1000 adults) in Small states in 2009 and the Depositors(per 1000 adults) in Tajikistan in 2011?
Keep it short and to the point. -243.79. What is the difference between the Depositors(per 1000 adults) of Moldova in 2009 and the Depositors(per 1000 adults) of Tajikistan in 2011?
Make the answer very short. 724.08. What is the difference between the Depositors(per 1000 adults) of Least developed countries in 2009 and the Depositors(per 1000 adults) of Small states in 2012?
Your answer should be compact. -312.47. What is the difference between the Depositors(per 1000 adults) in Least developed countries in 2009 and the Depositors(per 1000 adults) in Moldova in 2012?
Give a very brief answer. -1143.64. What is the difference between the Depositors(per 1000 adults) of Least developed countries in 2009 and the Depositors(per 1000 adults) of Tajikistan in 2012?
Ensure brevity in your answer.  -459.45. What is the difference between the Depositors(per 1000 adults) in Small states in 2009 and the Depositors(per 1000 adults) in Moldova in 2012?
Provide a succinct answer. -1068.88. What is the difference between the Depositors(per 1000 adults) of Small states in 2009 and the Depositors(per 1000 adults) of Tajikistan in 2012?
Your response must be concise. -384.69. What is the difference between the Depositors(per 1000 adults) in Moldova in 2009 and the Depositors(per 1000 adults) in Tajikistan in 2012?
Ensure brevity in your answer.  583.18. What is the difference between the Depositors(per 1000 adults) in Least developed countries in 2010 and the Depositors(per 1000 adults) in Small states in 2011?
Offer a terse response. -258.09. What is the difference between the Depositors(per 1000 adults) in Least developed countries in 2010 and the Depositors(per 1000 adults) in Moldova in 2011?
Offer a terse response. -1059.45. What is the difference between the Depositors(per 1000 adults) of Least developed countries in 2010 and the Depositors(per 1000 adults) of Tajikistan in 2011?
Provide a short and direct response. -303.62. What is the difference between the Depositors(per 1000 adults) in Small states in 2010 and the Depositors(per 1000 adults) in Moldova in 2011?
Make the answer very short. -991.72. What is the difference between the Depositors(per 1000 adults) of Small states in 2010 and the Depositors(per 1000 adults) of Tajikistan in 2011?
Make the answer very short. -235.89. What is the difference between the Depositors(per 1000 adults) in Moldova in 2010 and the Depositors(per 1000 adults) in Tajikistan in 2011?
Provide a short and direct response. 798.29. What is the difference between the Depositors(per 1000 adults) in Least developed countries in 2010 and the Depositors(per 1000 adults) in Small states in 2012?
Your response must be concise. -297.54. What is the difference between the Depositors(per 1000 adults) in Least developed countries in 2010 and the Depositors(per 1000 adults) in Moldova in 2012?
Ensure brevity in your answer.  -1128.7. What is the difference between the Depositors(per 1000 adults) of Least developed countries in 2010 and the Depositors(per 1000 adults) of Tajikistan in 2012?
Offer a terse response. -444.51. What is the difference between the Depositors(per 1000 adults) in Small states in 2010 and the Depositors(per 1000 adults) in Moldova in 2012?
Ensure brevity in your answer.  -1060.97. What is the difference between the Depositors(per 1000 adults) in Small states in 2010 and the Depositors(per 1000 adults) in Tajikistan in 2012?
Offer a terse response. -376.78. What is the difference between the Depositors(per 1000 adults) of Moldova in 2010 and the Depositors(per 1000 adults) of Tajikistan in 2012?
Give a very brief answer. 657.4. What is the difference between the Depositors(per 1000 adults) in Least developed countries in 2011 and the Depositors(per 1000 adults) in Small states in 2012?
Make the answer very short. -291.22. What is the difference between the Depositors(per 1000 adults) in Least developed countries in 2011 and the Depositors(per 1000 adults) in Moldova in 2012?
Your answer should be compact. -1122.38. What is the difference between the Depositors(per 1000 adults) of Least developed countries in 2011 and the Depositors(per 1000 adults) of Tajikistan in 2012?
Ensure brevity in your answer.  -438.19. What is the difference between the Depositors(per 1000 adults) in Small states in 2011 and the Depositors(per 1000 adults) in Moldova in 2012?
Ensure brevity in your answer.  -870.62. What is the difference between the Depositors(per 1000 adults) in Small states in 2011 and the Depositors(per 1000 adults) in Tajikistan in 2012?
Give a very brief answer. -186.42. What is the difference between the Depositors(per 1000 adults) in Moldova in 2011 and the Depositors(per 1000 adults) in Tajikistan in 2012?
Provide a succinct answer. 614.94. What is the average Depositors(per 1000 adults) of Least developed countries per year?
Give a very brief answer. 88.47. What is the average Depositors(per 1000 adults) in Small states per year?
Ensure brevity in your answer.  258.24. What is the average Depositors(per 1000 adults) of Moldova per year?
Offer a very short reply. 1075.94. What is the average Depositors(per 1000 adults) in Tajikistan per year?
Keep it short and to the point. 331.03. In the year 2005, what is the difference between the Depositors(per 1000 adults) of Least developed countries and Depositors(per 1000 adults) of Small states?
Provide a succinct answer. -219.85. In the year 2005, what is the difference between the Depositors(per 1000 adults) in Least developed countries and Depositors(per 1000 adults) in Moldova?
Provide a short and direct response. -788.52. In the year 2005, what is the difference between the Depositors(per 1000 adults) of Least developed countries and Depositors(per 1000 adults) of Tajikistan?
Provide a short and direct response. -138.1. In the year 2005, what is the difference between the Depositors(per 1000 adults) of Small states and Depositors(per 1000 adults) of Moldova?
Your answer should be compact. -568.67. In the year 2005, what is the difference between the Depositors(per 1000 adults) of Small states and Depositors(per 1000 adults) of Tajikistan?
Keep it short and to the point. 81.74. In the year 2005, what is the difference between the Depositors(per 1000 adults) in Moldova and Depositors(per 1000 adults) in Tajikistan?
Your response must be concise. 650.42. In the year 2006, what is the difference between the Depositors(per 1000 adults) in Least developed countries and Depositors(per 1000 adults) in Small states?
Offer a very short reply. -278.54. In the year 2006, what is the difference between the Depositors(per 1000 adults) in Least developed countries and Depositors(per 1000 adults) in Moldova?
Offer a very short reply. -844.41. In the year 2006, what is the difference between the Depositors(per 1000 adults) in Least developed countries and Depositors(per 1000 adults) in Tajikistan?
Offer a very short reply. -263.69. In the year 2006, what is the difference between the Depositors(per 1000 adults) in Small states and Depositors(per 1000 adults) in Moldova?
Provide a short and direct response. -565.87. In the year 2006, what is the difference between the Depositors(per 1000 adults) in Small states and Depositors(per 1000 adults) in Tajikistan?
Offer a very short reply. 14.84. In the year 2006, what is the difference between the Depositors(per 1000 adults) of Moldova and Depositors(per 1000 adults) of Tajikistan?
Ensure brevity in your answer.  580.72. In the year 2007, what is the difference between the Depositors(per 1000 adults) in Least developed countries and Depositors(per 1000 adults) in Small states?
Give a very brief answer. -118.26. In the year 2007, what is the difference between the Depositors(per 1000 adults) of Least developed countries and Depositors(per 1000 adults) of Moldova?
Make the answer very short. -947.12. In the year 2007, what is the difference between the Depositors(per 1000 adults) of Least developed countries and Depositors(per 1000 adults) of Tajikistan?
Offer a terse response. -169.78. In the year 2007, what is the difference between the Depositors(per 1000 adults) in Small states and Depositors(per 1000 adults) in Moldova?
Provide a short and direct response. -828.86. In the year 2007, what is the difference between the Depositors(per 1000 adults) of Small states and Depositors(per 1000 adults) of Tajikistan?
Keep it short and to the point. -51.52. In the year 2007, what is the difference between the Depositors(per 1000 adults) in Moldova and Depositors(per 1000 adults) in Tajikistan?
Keep it short and to the point. 777.35. In the year 2008, what is the difference between the Depositors(per 1000 adults) of Least developed countries and Depositors(per 1000 adults) of Small states?
Provide a short and direct response. -75.16. In the year 2008, what is the difference between the Depositors(per 1000 adults) of Least developed countries and Depositors(per 1000 adults) of Moldova?
Your answer should be compact. -1018.78. In the year 2008, what is the difference between the Depositors(per 1000 adults) in Least developed countries and Depositors(per 1000 adults) in Tajikistan?
Provide a short and direct response. -157.88. In the year 2008, what is the difference between the Depositors(per 1000 adults) in Small states and Depositors(per 1000 adults) in Moldova?
Make the answer very short. -943.62. In the year 2008, what is the difference between the Depositors(per 1000 adults) in Small states and Depositors(per 1000 adults) in Tajikistan?
Provide a short and direct response. -82.72. In the year 2008, what is the difference between the Depositors(per 1000 adults) of Moldova and Depositors(per 1000 adults) of Tajikistan?
Make the answer very short. 860.9. In the year 2009, what is the difference between the Depositors(per 1000 adults) in Least developed countries and Depositors(per 1000 adults) in Small states?
Give a very brief answer. -74.76. In the year 2009, what is the difference between the Depositors(per 1000 adults) of Least developed countries and Depositors(per 1000 adults) of Moldova?
Make the answer very short. -1042.63. In the year 2009, what is the difference between the Depositors(per 1000 adults) of Least developed countries and Depositors(per 1000 adults) of Tajikistan?
Provide a short and direct response. -234.35. In the year 2009, what is the difference between the Depositors(per 1000 adults) of Small states and Depositors(per 1000 adults) of Moldova?
Your answer should be compact. -967.87. In the year 2009, what is the difference between the Depositors(per 1000 adults) of Small states and Depositors(per 1000 adults) of Tajikistan?
Your response must be concise. -159.59. In the year 2009, what is the difference between the Depositors(per 1000 adults) of Moldova and Depositors(per 1000 adults) of Tajikistan?
Your answer should be very brief. 808.28. In the year 2010, what is the difference between the Depositors(per 1000 adults) in Least developed countries and Depositors(per 1000 adults) in Small states?
Keep it short and to the point. -67.73. In the year 2010, what is the difference between the Depositors(per 1000 adults) in Least developed countries and Depositors(per 1000 adults) in Moldova?
Your response must be concise. -1101.91. In the year 2010, what is the difference between the Depositors(per 1000 adults) in Least developed countries and Depositors(per 1000 adults) in Tajikistan?
Offer a terse response. -260.32. In the year 2010, what is the difference between the Depositors(per 1000 adults) of Small states and Depositors(per 1000 adults) of Moldova?
Ensure brevity in your answer.  -1034.18. In the year 2010, what is the difference between the Depositors(per 1000 adults) of Small states and Depositors(per 1000 adults) of Tajikistan?
Ensure brevity in your answer.  -192.58. In the year 2010, what is the difference between the Depositors(per 1000 adults) in Moldova and Depositors(per 1000 adults) in Tajikistan?
Offer a terse response. 841.59. In the year 2011, what is the difference between the Depositors(per 1000 adults) in Least developed countries and Depositors(per 1000 adults) in Small states?
Ensure brevity in your answer.  -251.77. In the year 2011, what is the difference between the Depositors(per 1000 adults) of Least developed countries and Depositors(per 1000 adults) of Moldova?
Ensure brevity in your answer.  -1053.13. In the year 2011, what is the difference between the Depositors(per 1000 adults) in Least developed countries and Depositors(per 1000 adults) in Tajikistan?
Keep it short and to the point. -297.3. In the year 2011, what is the difference between the Depositors(per 1000 adults) in Small states and Depositors(per 1000 adults) in Moldova?
Your answer should be very brief. -801.36. In the year 2011, what is the difference between the Depositors(per 1000 adults) of Small states and Depositors(per 1000 adults) of Tajikistan?
Your answer should be compact. -45.53. In the year 2011, what is the difference between the Depositors(per 1000 adults) in Moldova and Depositors(per 1000 adults) in Tajikistan?
Offer a very short reply. 755.83. In the year 2012, what is the difference between the Depositors(per 1000 adults) of Least developed countries and Depositors(per 1000 adults) of Small states?
Your answer should be very brief. -272.03. In the year 2012, what is the difference between the Depositors(per 1000 adults) in Least developed countries and Depositors(per 1000 adults) in Moldova?
Make the answer very short. -1103.2. In the year 2012, what is the difference between the Depositors(per 1000 adults) of Least developed countries and Depositors(per 1000 adults) of Tajikistan?
Ensure brevity in your answer.  -419. In the year 2012, what is the difference between the Depositors(per 1000 adults) in Small states and Depositors(per 1000 adults) in Moldova?
Provide a short and direct response. -831.17. In the year 2012, what is the difference between the Depositors(per 1000 adults) in Small states and Depositors(per 1000 adults) in Tajikistan?
Your response must be concise. -146.98. In the year 2012, what is the difference between the Depositors(per 1000 adults) of Moldova and Depositors(per 1000 adults) of Tajikistan?
Keep it short and to the point. 684.19. What is the ratio of the Depositors(per 1000 adults) in Least developed countries in 2005 to that in 2006?
Provide a succinct answer. 0.99. What is the ratio of the Depositors(per 1000 adults) in Small states in 2005 to that in 2006?
Your answer should be compact. 0.82. What is the ratio of the Depositors(per 1000 adults) of Moldova in 2005 to that in 2006?
Provide a short and direct response. 0.94. What is the ratio of the Depositors(per 1000 adults) in Tajikistan in 2005 to that in 2006?
Offer a very short reply. 0.61. What is the ratio of the Depositors(per 1000 adults) in Least developed countries in 2005 to that in 2007?
Offer a very short reply. 0.86. What is the ratio of the Depositors(per 1000 adults) of Small states in 2005 to that in 2007?
Provide a succinct answer. 1.49. What is the ratio of the Depositors(per 1000 adults) in Moldova in 2005 to that in 2007?
Offer a very short reply. 0.83. What is the ratio of the Depositors(per 1000 adults) in Tajikistan in 2005 to that in 2007?
Offer a terse response. 0.83. What is the ratio of the Depositors(per 1000 adults) in Least developed countries in 2005 to that in 2008?
Ensure brevity in your answer.  0.76. What is the ratio of the Depositors(per 1000 adults) in Small states in 2005 to that in 2008?
Offer a terse response. 1.82. What is the ratio of the Depositors(per 1000 adults) of Moldova in 2005 to that in 2008?
Make the answer very short. 0.77. What is the ratio of the Depositors(per 1000 adults) in Tajikistan in 2005 to that in 2008?
Ensure brevity in your answer.  0.84. What is the ratio of the Depositors(per 1000 adults) in Least developed countries in 2005 to that in 2009?
Offer a terse response. 0.64. What is the ratio of the Depositors(per 1000 adults) in Small states in 2005 to that in 2009?
Ensure brevity in your answer.  1.68. What is the ratio of the Depositors(per 1000 adults) of Moldova in 2005 to that in 2009?
Offer a very short reply. 0.75. What is the ratio of the Depositors(per 1000 adults) in Tajikistan in 2005 to that in 2009?
Your answer should be compact. 0.6. What is the ratio of the Depositors(per 1000 adults) in Least developed countries in 2005 to that in 2010?
Your answer should be very brief. 0.55. What is the ratio of the Depositors(per 1000 adults) of Small states in 2005 to that in 2010?
Offer a very short reply. 1.6. What is the ratio of the Depositors(per 1000 adults) of Moldova in 2005 to that in 2010?
Offer a terse response. 0.7. What is the ratio of the Depositors(per 1000 adults) of Tajikistan in 2005 to that in 2010?
Offer a very short reply. 0.54. What is the ratio of the Depositors(per 1000 adults) in Least developed countries in 2005 to that in 2011?
Offer a terse response. 0.52. What is the ratio of the Depositors(per 1000 adults) in Small states in 2005 to that in 2011?
Give a very brief answer. 0.76. What is the ratio of the Depositors(per 1000 adults) in Moldova in 2005 to that in 2011?
Your answer should be compact. 0.73. What is the ratio of the Depositors(per 1000 adults) of Tajikistan in 2005 to that in 2011?
Keep it short and to the point. 0.48. What is the ratio of the Depositors(per 1000 adults) of Least developed countries in 2005 to that in 2012?
Your response must be concise. 0.45. What is the ratio of the Depositors(per 1000 adults) in Small states in 2005 to that in 2012?
Give a very brief answer. 0.69. What is the ratio of the Depositors(per 1000 adults) of Moldova in 2005 to that in 2012?
Ensure brevity in your answer.  0.69. What is the ratio of the Depositors(per 1000 adults) of Tajikistan in 2005 to that in 2012?
Keep it short and to the point. 0.36. What is the ratio of the Depositors(per 1000 adults) in Least developed countries in 2006 to that in 2007?
Offer a very short reply. 0.87. What is the ratio of the Depositors(per 1000 adults) of Small states in 2006 to that in 2007?
Give a very brief answer. 1.81. What is the ratio of the Depositors(per 1000 adults) of Moldova in 2006 to that in 2007?
Ensure brevity in your answer.  0.89. What is the ratio of the Depositors(per 1000 adults) in Tajikistan in 2006 to that in 2007?
Your response must be concise. 1.36. What is the ratio of the Depositors(per 1000 adults) of Least developed countries in 2006 to that in 2008?
Your answer should be compact. 0.76. What is the ratio of the Depositors(per 1000 adults) in Small states in 2006 to that in 2008?
Offer a terse response. 2.21. What is the ratio of the Depositors(per 1000 adults) in Moldova in 2006 to that in 2008?
Provide a short and direct response. 0.82. What is the ratio of the Depositors(per 1000 adults) in Tajikistan in 2006 to that in 2008?
Ensure brevity in your answer.  1.37. What is the ratio of the Depositors(per 1000 adults) in Least developed countries in 2006 to that in 2009?
Provide a succinct answer. 0.65. What is the ratio of the Depositors(per 1000 adults) of Small states in 2006 to that in 2009?
Your response must be concise. 2.03. What is the ratio of the Depositors(per 1000 adults) of Moldova in 2006 to that in 2009?
Provide a short and direct response. 0.8. What is the ratio of the Depositors(per 1000 adults) of Least developed countries in 2006 to that in 2010?
Your response must be concise. 0.56. What is the ratio of the Depositors(per 1000 adults) in Small states in 2006 to that in 2010?
Offer a terse response. 1.94. What is the ratio of the Depositors(per 1000 adults) of Moldova in 2006 to that in 2010?
Offer a terse response. 0.75. What is the ratio of the Depositors(per 1000 adults) of Tajikistan in 2006 to that in 2010?
Offer a very short reply. 0.88. What is the ratio of the Depositors(per 1000 adults) in Least developed countries in 2006 to that in 2011?
Offer a very short reply. 0.53. What is the ratio of the Depositors(per 1000 adults) in Small states in 2006 to that in 2011?
Offer a terse response. 0.93. What is the ratio of the Depositors(per 1000 adults) of Moldova in 2006 to that in 2011?
Give a very brief answer. 0.78. What is the ratio of the Depositors(per 1000 adults) of Tajikistan in 2006 to that in 2011?
Provide a succinct answer. 0.79. What is the ratio of the Depositors(per 1000 adults) in Least developed countries in 2006 to that in 2012?
Keep it short and to the point. 0.45. What is the ratio of the Depositors(per 1000 adults) in Small states in 2006 to that in 2012?
Offer a very short reply. 0.84. What is the ratio of the Depositors(per 1000 adults) of Moldova in 2006 to that in 2012?
Provide a succinct answer. 0.73. What is the ratio of the Depositors(per 1000 adults) in Tajikistan in 2006 to that in 2012?
Provide a succinct answer. 0.59. What is the ratio of the Depositors(per 1000 adults) in Least developed countries in 2007 to that in 2008?
Make the answer very short. 0.88. What is the ratio of the Depositors(per 1000 adults) of Small states in 2007 to that in 2008?
Make the answer very short. 1.22. What is the ratio of the Depositors(per 1000 adults) of Moldova in 2007 to that in 2008?
Provide a succinct answer. 0.93. What is the ratio of the Depositors(per 1000 adults) in Tajikistan in 2007 to that in 2008?
Your response must be concise. 1.01. What is the ratio of the Depositors(per 1000 adults) of Least developed countries in 2007 to that in 2009?
Your answer should be compact. 0.75. What is the ratio of the Depositors(per 1000 adults) of Small states in 2007 to that in 2009?
Keep it short and to the point. 1.12. What is the ratio of the Depositors(per 1000 adults) of Moldova in 2007 to that in 2009?
Offer a terse response. 0.9. What is the ratio of the Depositors(per 1000 adults) in Tajikistan in 2007 to that in 2009?
Your answer should be very brief. 0.73. What is the ratio of the Depositors(per 1000 adults) in Least developed countries in 2007 to that in 2010?
Offer a terse response. 0.64. What is the ratio of the Depositors(per 1000 adults) in Small states in 2007 to that in 2010?
Make the answer very short. 1.07. What is the ratio of the Depositors(per 1000 adults) in Moldova in 2007 to that in 2010?
Make the answer very short. 0.84. What is the ratio of the Depositors(per 1000 adults) in Tajikistan in 2007 to that in 2010?
Your answer should be very brief. 0.65. What is the ratio of the Depositors(per 1000 adults) in Least developed countries in 2007 to that in 2011?
Keep it short and to the point. 0.61. What is the ratio of the Depositors(per 1000 adults) of Small states in 2007 to that in 2011?
Ensure brevity in your answer.  0.51. What is the ratio of the Depositors(per 1000 adults) in Moldova in 2007 to that in 2011?
Your response must be concise. 0.87. What is the ratio of the Depositors(per 1000 adults) in Tajikistan in 2007 to that in 2011?
Provide a succinct answer. 0.58. What is the ratio of the Depositors(per 1000 adults) in Least developed countries in 2007 to that in 2012?
Ensure brevity in your answer.  0.52. What is the ratio of the Depositors(per 1000 adults) of Small states in 2007 to that in 2012?
Offer a terse response. 0.46. What is the ratio of the Depositors(per 1000 adults) of Moldova in 2007 to that in 2012?
Your answer should be very brief. 0.82. What is the ratio of the Depositors(per 1000 adults) of Tajikistan in 2007 to that in 2012?
Make the answer very short. 0.43. What is the ratio of the Depositors(per 1000 adults) in Least developed countries in 2008 to that in 2009?
Offer a terse response. 0.85. What is the ratio of the Depositors(per 1000 adults) in Small states in 2008 to that in 2009?
Offer a very short reply. 0.92. What is the ratio of the Depositors(per 1000 adults) in Moldova in 2008 to that in 2009?
Offer a terse response. 0.97. What is the ratio of the Depositors(per 1000 adults) of Tajikistan in 2008 to that in 2009?
Keep it short and to the point. 0.72. What is the ratio of the Depositors(per 1000 adults) in Least developed countries in 2008 to that in 2010?
Give a very brief answer. 0.73. What is the ratio of the Depositors(per 1000 adults) in Small states in 2008 to that in 2010?
Provide a succinct answer. 0.88. What is the ratio of the Depositors(per 1000 adults) of Moldova in 2008 to that in 2010?
Ensure brevity in your answer.  0.91. What is the ratio of the Depositors(per 1000 adults) in Tajikistan in 2008 to that in 2010?
Offer a very short reply. 0.64. What is the ratio of the Depositors(per 1000 adults) in Least developed countries in 2008 to that in 2011?
Provide a short and direct response. 0.69. What is the ratio of the Depositors(per 1000 adults) of Small states in 2008 to that in 2011?
Your answer should be very brief. 0.42. What is the ratio of the Depositors(per 1000 adults) in Moldova in 2008 to that in 2011?
Offer a terse response. 0.94. What is the ratio of the Depositors(per 1000 adults) of Tajikistan in 2008 to that in 2011?
Give a very brief answer. 0.57. What is the ratio of the Depositors(per 1000 adults) in Least developed countries in 2008 to that in 2012?
Your answer should be very brief. 0.59. What is the ratio of the Depositors(per 1000 adults) in Small states in 2008 to that in 2012?
Offer a very short reply. 0.38. What is the ratio of the Depositors(per 1000 adults) of Moldova in 2008 to that in 2012?
Provide a succinct answer. 0.89. What is the ratio of the Depositors(per 1000 adults) of Tajikistan in 2008 to that in 2012?
Offer a terse response. 0.43. What is the ratio of the Depositors(per 1000 adults) in Least developed countries in 2009 to that in 2010?
Offer a very short reply. 0.86. What is the ratio of the Depositors(per 1000 adults) in Small states in 2009 to that in 2010?
Keep it short and to the point. 0.95. What is the ratio of the Depositors(per 1000 adults) of Moldova in 2009 to that in 2010?
Give a very brief answer. 0.94. What is the ratio of the Depositors(per 1000 adults) in Tajikistan in 2009 to that in 2010?
Provide a short and direct response. 0.89. What is the ratio of the Depositors(per 1000 adults) in Least developed countries in 2009 to that in 2011?
Provide a short and direct response. 0.81. What is the ratio of the Depositors(per 1000 adults) of Small states in 2009 to that in 2011?
Ensure brevity in your answer.  0.46. What is the ratio of the Depositors(per 1000 adults) in Moldova in 2009 to that in 2011?
Ensure brevity in your answer.  0.97. What is the ratio of the Depositors(per 1000 adults) of Tajikistan in 2009 to that in 2011?
Offer a very short reply. 0.79. What is the ratio of the Depositors(per 1000 adults) of Least developed countries in 2009 to that in 2012?
Your answer should be very brief. 0.69. What is the ratio of the Depositors(per 1000 adults) in Small states in 2009 to that in 2012?
Make the answer very short. 0.41. What is the ratio of the Depositors(per 1000 adults) in Moldova in 2009 to that in 2012?
Your answer should be very brief. 0.92. What is the ratio of the Depositors(per 1000 adults) of Tajikistan in 2009 to that in 2012?
Ensure brevity in your answer.  0.59. What is the ratio of the Depositors(per 1000 adults) in Least developed countries in 2010 to that in 2011?
Your answer should be compact. 0.94. What is the ratio of the Depositors(per 1000 adults) in Small states in 2010 to that in 2011?
Offer a terse response. 0.48. What is the ratio of the Depositors(per 1000 adults) in Moldova in 2010 to that in 2011?
Make the answer very short. 1.04. What is the ratio of the Depositors(per 1000 adults) of Tajikistan in 2010 to that in 2011?
Your answer should be compact. 0.89. What is the ratio of the Depositors(per 1000 adults) of Least developed countries in 2010 to that in 2012?
Keep it short and to the point. 0.81. What is the ratio of the Depositors(per 1000 adults) in Small states in 2010 to that in 2012?
Your answer should be compact. 0.43. What is the ratio of the Depositors(per 1000 adults) in Moldova in 2010 to that in 2012?
Offer a terse response. 0.98. What is the ratio of the Depositors(per 1000 adults) of Tajikistan in 2010 to that in 2012?
Make the answer very short. 0.67. What is the ratio of the Depositors(per 1000 adults) of Least developed countries in 2011 to that in 2012?
Provide a short and direct response. 0.85. What is the ratio of the Depositors(per 1000 adults) of Small states in 2011 to that in 2012?
Your answer should be compact. 0.9. What is the ratio of the Depositors(per 1000 adults) of Moldova in 2011 to that in 2012?
Your response must be concise. 0.94. What is the ratio of the Depositors(per 1000 adults) in Tajikistan in 2011 to that in 2012?
Your answer should be very brief. 0.74. What is the difference between the highest and the second highest Depositors(per 1000 adults) of Least developed countries?
Keep it short and to the point. 19.19. What is the difference between the highest and the second highest Depositors(per 1000 adults) of Small states?
Provide a succinct answer. 39.45. What is the difference between the highest and the second highest Depositors(per 1000 adults) of Moldova?
Offer a terse response. 26.79. What is the difference between the highest and the second highest Depositors(per 1000 adults) in Tajikistan?
Offer a terse response. 140.89. What is the difference between the highest and the lowest Depositors(per 1000 adults) in Least developed countries?
Your response must be concise. 72.97. What is the difference between the highest and the lowest Depositors(per 1000 adults) in Small states?
Your answer should be compact. 250.91. What is the difference between the highest and the lowest Depositors(per 1000 adults) in Moldova?
Provide a succinct answer. 387.65. What is the difference between the highest and the lowest Depositors(per 1000 adults) of Tajikistan?
Offer a very short reply. 353.87. 